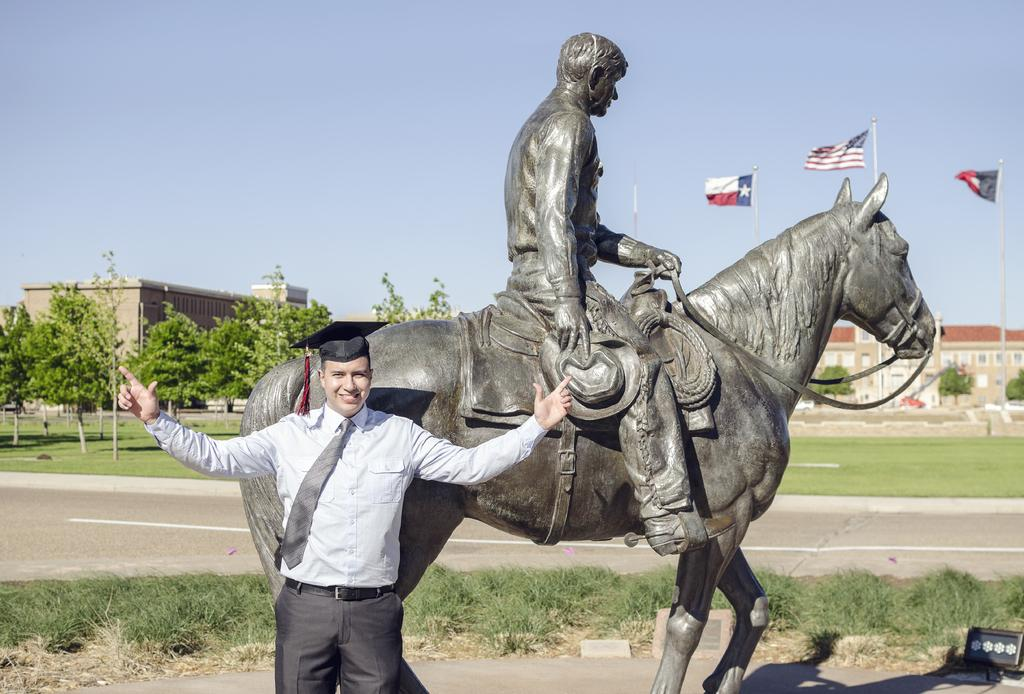Who is present in the image? There is a man in the image. What is the man doing in the image? The man is posing for a camera. What other object or structure can be seen in the image? There is a statue of a man riding a horse in the image. How many rings can be seen on the boy's finger in the image? There is no boy present in the image, and therefore no rings can be seen on a boy's finger. Is there a tub visible in the image? There is no tub present in the image. 